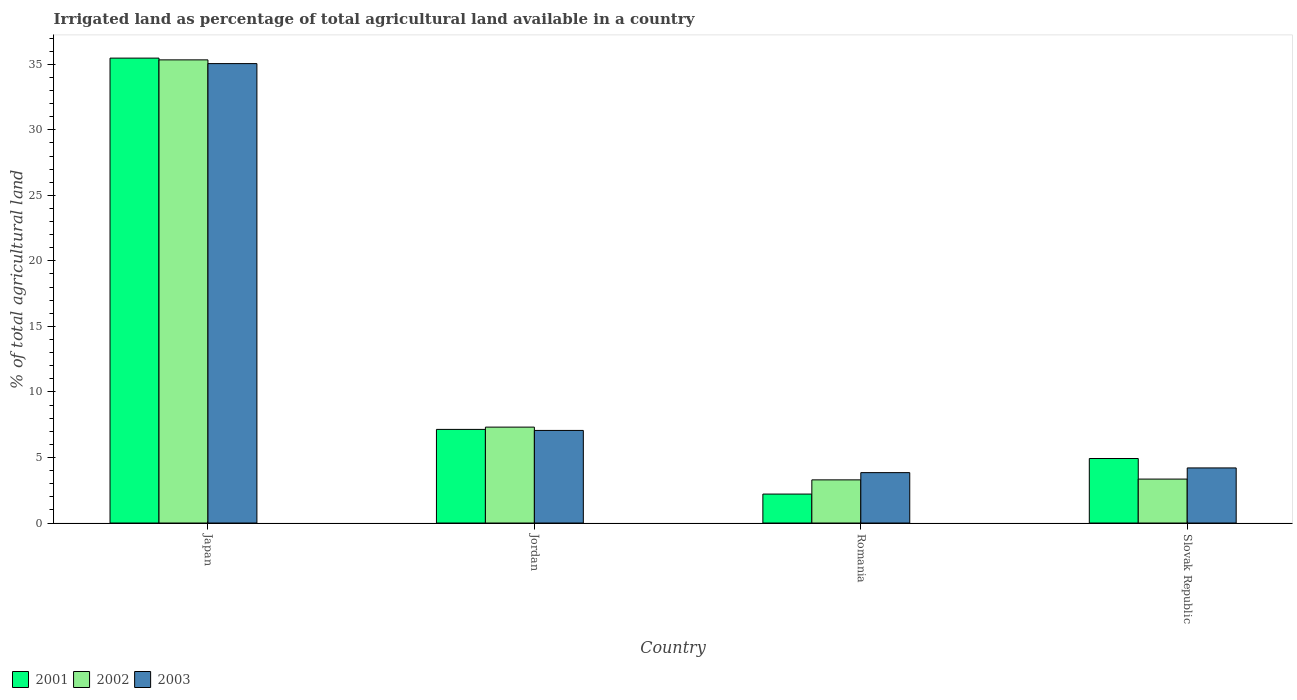Are the number of bars on each tick of the X-axis equal?
Provide a short and direct response. Yes. How many bars are there on the 1st tick from the left?
Make the answer very short. 3. How many bars are there on the 4th tick from the right?
Offer a terse response. 3. What is the percentage of irrigated land in 2003 in Romania?
Your answer should be very brief. 3.84. Across all countries, what is the maximum percentage of irrigated land in 2002?
Provide a short and direct response. 35.33. Across all countries, what is the minimum percentage of irrigated land in 2001?
Provide a succinct answer. 2.21. In which country was the percentage of irrigated land in 2003 maximum?
Your response must be concise. Japan. In which country was the percentage of irrigated land in 2003 minimum?
Provide a short and direct response. Romania. What is the total percentage of irrigated land in 2001 in the graph?
Your answer should be very brief. 49.74. What is the difference between the percentage of irrigated land in 2002 in Japan and that in Jordan?
Ensure brevity in your answer.  28.02. What is the difference between the percentage of irrigated land in 2001 in Slovak Republic and the percentage of irrigated land in 2003 in Jordan?
Your response must be concise. -2.14. What is the average percentage of irrigated land in 2002 per country?
Offer a very short reply. 12.32. What is the difference between the percentage of irrigated land of/in 2003 and percentage of irrigated land of/in 2001 in Slovak Republic?
Your answer should be very brief. -0.72. In how many countries, is the percentage of irrigated land in 2002 greater than 18 %?
Offer a terse response. 1. What is the ratio of the percentage of irrigated land in 2003 in Japan to that in Slovak Republic?
Your response must be concise. 8.34. Is the percentage of irrigated land in 2001 in Jordan less than that in Slovak Republic?
Your response must be concise. No. Is the difference between the percentage of irrigated land in 2003 in Japan and Slovak Republic greater than the difference between the percentage of irrigated land in 2001 in Japan and Slovak Republic?
Ensure brevity in your answer.  Yes. What is the difference between the highest and the second highest percentage of irrigated land in 2001?
Your answer should be very brief. 30.55. What is the difference between the highest and the lowest percentage of irrigated land in 2002?
Provide a short and direct response. 32.04. In how many countries, is the percentage of irrigated land in 2002 greater than the average percentage of irrigated land in 2002 taken over all countries?
Provide a short and direct response. 1. What does the 2nd bar from the left in Romania represents?
Offer a very short reply. 2002. Is it the case that in every country, the sum of the percentage of irrigated land in 2001 and percentage of irrigated land in 2002 is greater than the percentage of irrigated land in 2003?
Provide a short and direct response. Yes. Are all the bars in the graph horizontal?
Your answer should be compact. No. How many countries are there in the graph?
Your response must be concise. 4. Are the values on the major ticks of Y-axis written in scientific E-notation?
Make the answer very short. No. Does the graph contain any zero values?
Provide a short and direct response. No. Does the graph contain grids?
Your answer should be compact. No. How many legend labels are there?
Make the answer very short. 3. What is the title of the graph?
Give a very brief answer. Irrigated land as percentage of total agricultural land available in a country. What is the label or title of the Y-axis?
Your answer should be compact. % of total agricultural land. What is the % of total agricultural land in 2001 in Japan?
Ensure brevity in your answer.  35.47. What is the % of total agricultural land in 2002 in Japan?
Offer a very short reply. 35.33. What is the % of total agricultural land in 2003 in Japan?
Offer a very short reply. 35.05. What is the % of total agricultural land in 2001 in Jordan?
Provide a short and direct response. 7.14. What is the % of total agricultural land in 2002 in Jordan?
Offer a terse response. 7.32. What is the % of total agricultural land in 2003 in Jordan?
Provide a succinct answer. 7.06. What is the % of total agricultural land of 2001 in Romania?
Offer a very short reply. 2.21. What is the % of total agricultural land in 2002 in Romania?
Make the answer very short. 3.29. What is the % of total agricultural land in 2003 in Romania?
Offer a terse response. 3.84. What is the % of total agricultural land in 2001 in Slovak Republic?
Give a very brief answer. 4.92. What is the % of total agricultural land in 2002 in Slovak Republic?
Make the answer very short. 3.35. What is the % of total agricultural land of 2003 in Slovak Republic?
Your answer should be very brief. 4.2. Across all countries, what is the maximum % of total agricultural land in 2001?
Ensure brevity in your answer.  35.47. Across all countries, what is the maximum % of total agricultural land in 2002?
Provide a short and direct response. 35.33. Across all countries, what is the maximum % of total agricultural land of 2003?
Your response must be concise. 35.05. Across all countries, what is the minimum % of total agricultural land in 2001?
Your answer should be very brief. 2.21. Across all countries, what is the minimum % of total agricultural land of 2002?
Keep it short and to the point. 3.29. Across all countries, what is the minimum % of total agricultural land in 2003?
Ensure brevity in your answer.  3.84. What is the total % of total agricultural land of 2001 in the graph?
Offer a terse response. 49.74. What is the total % of total agricultural land of 2002 in the graph?
Your answer should be compact. 49.3. What is the total % of total agricultural land in 2003 in the graph?
Ensure brevity in your answer.  50.16. What is the difference between the % of total agricultural land of 2001 in Japan and that in Jordan?
Ensure brevity in your answer.  28.33. What is the difference between the % of total agricultural land of 2002 in Japan and that in Jordan?
Make the answer very short. 28.02. What is the difference between the % of total agricultural land in 2003 in Japan and that in Jordan?
Provide a succinct answer. 27.99. What is the difference between the % of total agricultural land of 2001 in Japan and that in Romania?
Ensure brevity in your answer.  33.26. What is the difference between the % of total agricultural land in 2002 in Japan and that in Romania?
Your response must be concise. 32.04. What is the difference between the % of total agricultural land in 2003 in Japan and that in Romania?
Your answer should be compact. 31.21. What is the difference between the % of total agricultural land of 2001 in Japan and that in Slovak Republic?
Offer a terse response. 30.55. What is the difference between the % of total agricultural land in 2002 in Japan and that in Slovak Republic?
Ensure brevity in your answer.  31.98. What is the difference between the % of total agricultural land in 2003 in Japan and that in Slovak Republic?
Your response must be concise. 30.85. What is the difference between the % of total agricultural land of 2001 in Jordan and that in Romania?
Offer a terse response. 4.93. What is the difference between the % of total agricultural land in 2002 in Jordan and that in Romania?
Provide a short and direct response. 4.02. What is the difference between the % of total agricultural land in 2003 in Jordan and that in Romania?
Your response must be concise. 3.22. What is the difference between the % of total agricultural land in 2001 in Jordan and that in Slovak Republic?
Provide a succinct answer. 2.22. What is the difference between the % of total agricultural land of 2002 in Jordan and that in Slovak Republic?
Give a very brief answer. 3.96. What is the difference between the % of total agricultural land of 2003 in Jordan and that in Slovak Republic?
Keep it short and to the point. 2.86. What is the difference between the % of total agricultural land in 2001 in Romania and that in Slovak Republic?
Ensure brevity in your answer.  -2.71. What is the difference between the % of total agricultural land in 2002 in Romania and that in Slovak Republic?
Offer a terse response. -0.06. What is the difference between the % of total agricultural land of 2003 in Romania and that in Slovak Republic?
Your response must be concise. -0.36. What is the difference between the % of total agricultural land in 2001 in Japan and the % of total agricultural land in 2002 in Jordan?
Make the answer very short. 28.15. What is the difference between the % of total agricultural land of 2001 in Japan and the % of total agricultural land of 2003 in Jordan?
Your answer should be compact. 28.4. What is the difference between the % of total agricultural land in 2002 in Japan and the % of total agricultural land in 2003 in Jordan?
Provide a succinct answer. 28.27. What is the difference between the % of total agricultural land in 2001 in Japan and the % of total agricultural land in 2002 in Romania?
Keep it short and to the point. 32.18. What is the difference between the % of total agricultural land in 2001 in Japan and the % of total agricultural land in 2003 in Romania?
Offer a terse response. 31.62. What is the difference between the % of total agricultural land of 2002 in Japan and the % of total agricultural land of 2003 in Romania?
Your answer should be compact. 31.49. What is the difference between the % of total agricultural land in 2001 in Japan and the % of total agricultural land in 2002 in Slovak Republic?
Ensure brevity in your answer.  32.12. What is the difference between the % of total agricultural land of 2001 in Japan and the % of total agricultural land of 2003 in Slovak Republic?
Your answer should be compact. 31.26. What is the difference between the % of total agricultural land in 2002 in Japan and the % of total agricultural land in 2003 in Slovak Republic?
Offer a terse response. 31.13. What is the difference between the % of total agricultural land in 2001 in Jordan and the % of total agricultural land in 2002 in Romania?
Give a very brief answer. 3.85. What is the difference between the % of total agricultural land of 2001 in Jordan and the % of total agricultural land of 2003 in Romania?
Ensure brevity in your answer.  3.3. What is the difference between the % of total agricultural land in 2002 in Jordan and the % of total agricultural land in 2003 in Romania?
Keep it short and to the point. 3.47. What is the difference between the % of total agricultural land of 2001 in Jordan and the % of total agricultural land of 2002 in Slovak Republic?
Give a very brief answer. 3.79. What is the difference between the % of total agricultural land in 2001 in Jordan and the % of total agricultural land in 2003 in Slovak Republic?
Offer a terse response. 2.94. What is the difference between the % of total agricultural land of 2002 in Jordan and the % of total agricultural land of 2003 in Slovak Republic?
Provide a succinct answer. 3.11. What is the difference between the % of total agricultural land of 2001 in Romania and the % of total agricultural land of 2002 in Slovak Republic?
Your response must be concise. -1.14. What is the difference between the % of total agricultural land of 2001 in Romania and the % of total agricultural land of 2003 in Slovak Republic?
Your response must be concise. -1.99. What is the difference between the % of total agricultural land in 2002 in Romania and the % of total agricultural land in 2003 in Slovak Republic?
Offer a very short reply. -0.91. What is the average % of total agricultural land of 2001 per country?
Give a very brief answer. 12.44. What is the average % of total agricultural land in 2002 per country?
Ensure brevity in your answer.  12.32. What is the average % of total agricultural land of 2003 per country?
Your answer should be compact. 12.54. What is the difference between the % of total agricultural land of 2001 and % of total agricultural land of 2002 in Japan?
Keep it short and to the point. 0.13. What is the difference between the % of total agricultural land of 2001 and % of total agricultural land of 2003 in Japan?
Give a very brief answer. 0.42. What is the difference between the % of total agricultural land in 2002 and % of total agricultural land in 2003 in Japan?
Your answer should be very brief. 0.28. What is the difference between the % of total agricultural land of 2001 and % of total agricultural land of 2002 in Jordan?
Make the answer very short. -0.17. What is the difference between the % of total agricultural land in 2001 and % of total agricultural land in 2003 in Jordan?
Give a very brief answer. 0.08. What is the difference between the % of total agricultural land in 2002 and % of total agricultural land in 2003 in Jordan?
Ensure brevity in your answer.  0.25. What is the difference between the % of total agricultural land in 2001 and % of total agricultural land in 2002 in Romania?
Your answer should be compact. -1.08. What is the difference between the % of total agricultural land of 2001 and % of total agricultural land of 2003 in Romania?
Provide a succinct answer. -1.63. What is the difference between the % of total agricultural land in 2002 and % of total agricultural land in 2003 in Romania?
Your answer should be compact. -0.55. What is the difference between the % of total agricultural land in 2001 and % of total agricultural land in 2002 in Slovak Republic?
Provide a short and direct response. 1.57. What is the difference between the % of total agricultural land in 2001 and % of total agricultural land in 2003 in Slovak Republic?
Your answer should be compact. 0.72. What is the difference between the % of total agricultural land of 2002 and % of total agricultural land of 2003 in Slovak Republic?
Your answer should be compact. -0.85. What is the ratio of the % of total agricultural land of 2001 in Japan to that in Jordan?
Your answer should be very brief. 4.97. What is the ratio of the % of total agricultural land in 2002 in Japan to that in Jordan?
Offer a very short reply. 4.83. What is the ratio of the % of total agricultural land in 2003 in Japan to that in Jordan?
Provide a succinct answer. 4.96. What is the ratio of the % of total agricultural land in 2001 in Japan to that in Romania?
Offer a terse response. 16.05. What is the ratio of the % of total agricultural land in 2002 in Japan to that in Romania?
Your response must be concise. 10.73. What is the ratio of the % of total agricultural land in 2003 in Japan to that in Romania?
Provide a short and direct response. 9.12. What is the ratio of the % of total agricultural land in 2001 in Japan to that in Slovak Republic?
Your response must be concise. 7.21. What is the ratio of the % of total agricultural land in 2002 in Japan to that in Slovak Republic?
Give a very brief answer. 10.54. What is the ratio of the % of total agricultural land of 2003 in Japan to that in Slovak Republic?
Offer a terse response. 8.34. What is the ratio of the % of total agricultural land in 2001 in Jordan to that in Romania?
Provide a short and direct response. 3.23. What is the ratio of the % of total agricultural land of 2002 in Jordan to that in Romania?
Give a very brief answer. 2.22. What is the ratio of the % of total agricultural land of 2003 in Jordan to that in Romania?
Make the answer very short. 1.84. What is the ratio of the % of total agricultural land in 2001 in Jordan to that in Slovak Republic?
Ensure brevity in your answer.  1.45. What is the ratio of the % of total agricultural land of 2002 in Jordan to that in Slovak Republic?
Offer a very short reply. 2.18. What is the ratio of the % of total agricultural land in 2003 in Jordan to that in Slovak Republic?
Give a very brief answer. 1.68. What is the ratio of the % of total agricultural land in 2001 in Romania to that in Slovak Republic?
Offer a terse response. 0.45. What is the ratio of the % of total agricultural land in 2002 in Romania to that in Slovak Republic?
Ensure brevity in your answer.  0.98. What is the ratio of the % of total agricultural land of 2003 in Romania to that in Slovak Republic?
Give a very brief answer. 0.91. What is the difference between the highest and the second highest % of total agricultural land in 2001?
Give a very brief answer. 28.33. What is the difference between the highest and the second highest % of total agricultural land of 2002?
Provide a succinct answer. 28.02. What is the difference between the highest and the second highest % of total agricultural land of 2003?
Your answer should be compact. 27.99. What is the difference between the highest and the lowest % of total agricultural land of 2001?
Your answer should be compact. 33.26. What is the difference between the highest and the lowest % of total agricultural land of 2002?
Keep it short and to the point. 32.04. What is the difference between the highest and the lowest % of total agricultural land in 2003?
Your response must be concise. 31.21. 